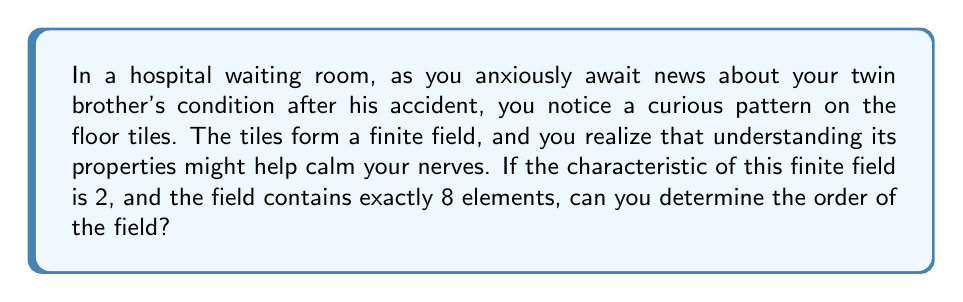Provide a solution to this math problem. Let's approach this step-by-step:

1) In a finite field, the number of elements is always a power of the characteristic. We can express this as:

   $$|F| = p^n$$

   where $|F|$ is the order of the field, $p$ is the characteristic, and $n$ is some positive integer.

2) We're given that the characteristic is 2, so $p = 2$.

3) We're also told that the field contains exactly 8 elements, so $|F| = 8$.

4) Now, we need to find $n$ such that:

   $$2^n = 8$$

5) We can solve this by using logarithms:

   $$\log_2(2^n) = \log_2(8)$$
   $$n = 3$$

6) Therefore, the order of the field is:

   $$|F| = 2^3 = 8$$

The order of a finite field is the number of elements in the field, which in this case is 8.
Answer: 8 